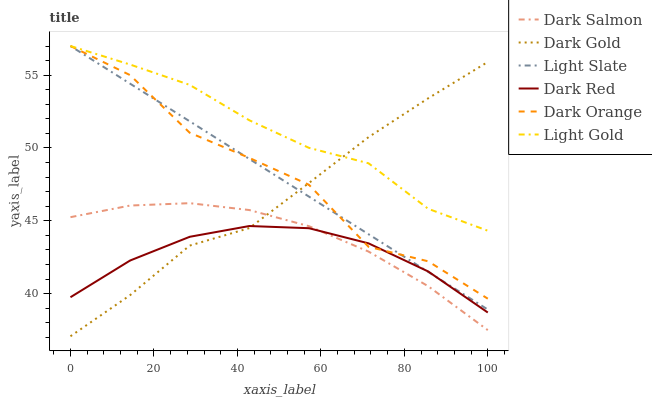Does Dark Red have the minimum area under the curve?
Answer yes or no. Yes. Does Light Gold have the maximum area under the curve?
Answer yes or no. Yes. Does Dark Gold have the minimum area under the curve?
Answer yes or no. No. Does Dark Gold have the maximum area under the curve?
Answer yes or no. No. Is Light Slate the smoothest?
Answer yes or no. Yes. Is Dark Orange the roughest?
Answer yes or no. Yes. Is Dark Gold the smoothest?
Answer yes or no. No. Is Dark Gold the roughest?
Answer yes or no. No. Does Dark Gold have the lowest value?
Answer yes or no. Yes. Does Light Slate have the lowest value?
Answer yes or no. No. Does Light Gold have the highest value?
Answer yes or no. Yes. Does Dark Gold have the highest value?
Answer yes or no. No. Is Dark Salmon less than Light Gold?
Answer yes or no. Yes. Is Dark Orange greater than Dark Salmon?
Answer yes or no. Yes. Does Dark Orange intersect Dark Gold?
Answer yes or no. Yes. Is Dark Orange less than Dark Gold?
Answer yes or no. No. Is Dark Orange greater than Dark Gold?
Answer yes or no. No. Does Dark Salmon intersect Light Gold?
Answer yes or no. No. 